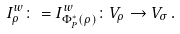Convert formula to latex. <formula><loc_0><loc_0><loc_500><loc_500>I ^ { w } _ { \rho } \colon = I ^ { w } _ { \Phi _ { P } ^ { * } ( \rho ) } \colon V _ { \rho } \to V _ { \sigma } \, .</formula> 